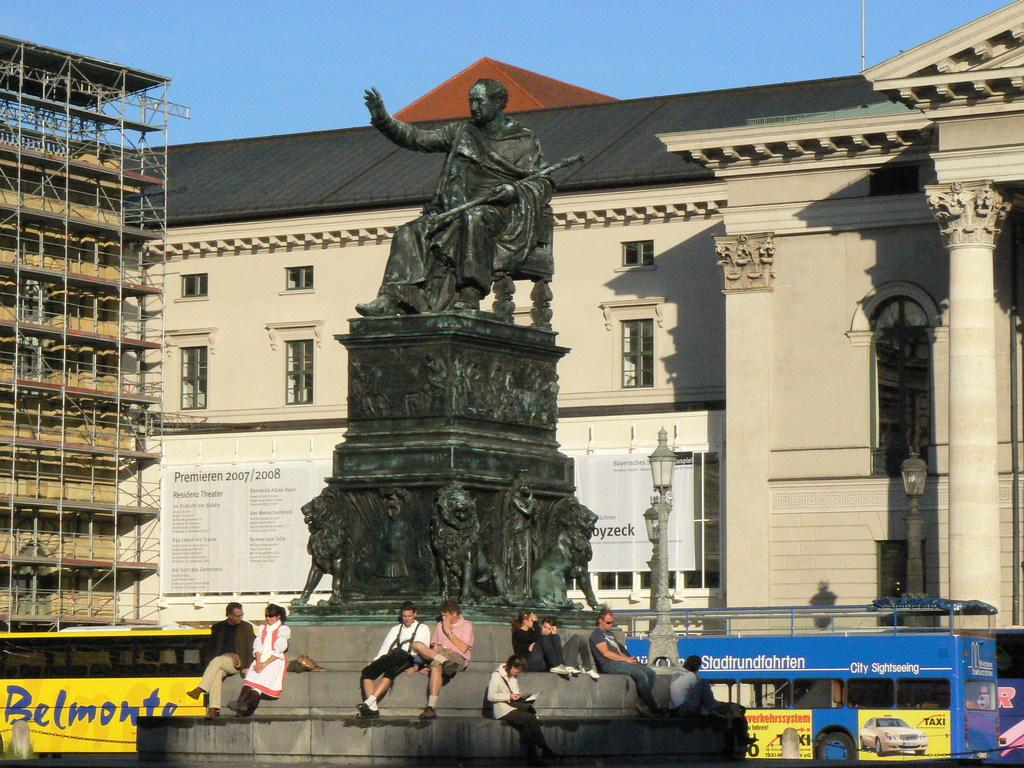What is the main subject in the image? There is a statue in the image. What are the people in the image doing? People are sitting on the steps at the bottom of the image. What can be seen in the background of the image? There are buses and buildings in the background of the image. What is visible at the top of the image? The sky is visible at the top of the image. What type of flower is growing on the statue in the image? There is no flower growing on the statue in the image. How does the wind affect the buses in the background of the image? There is no mention of wind in the image, and its effect on the buses cannot be determined. 